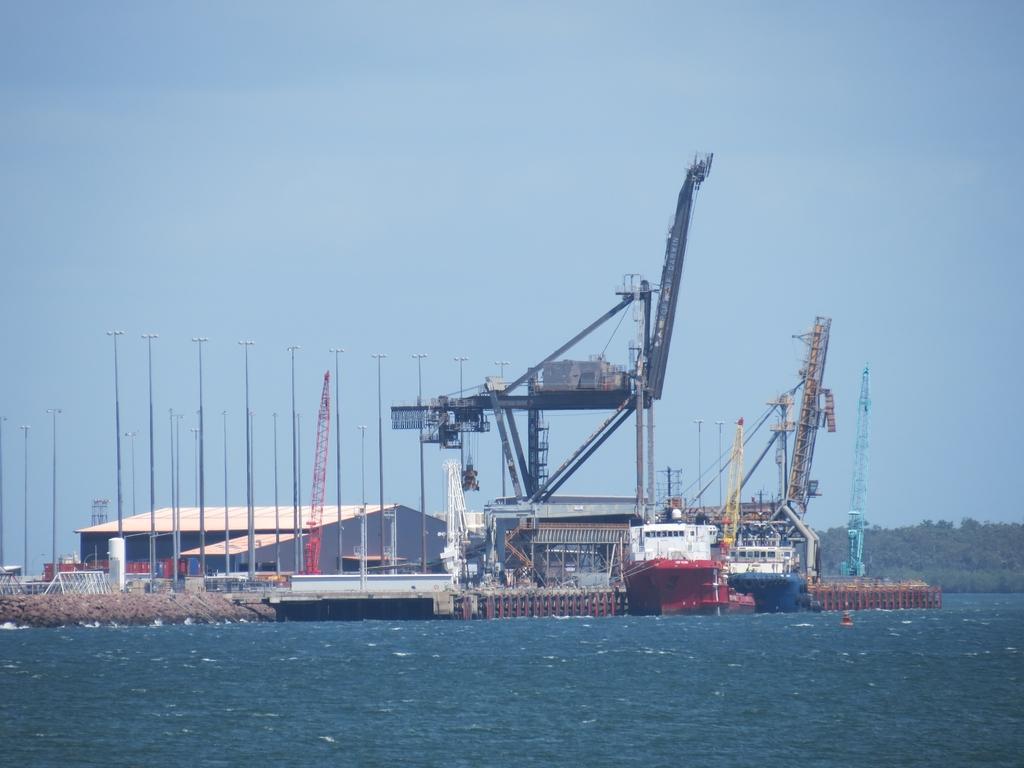Describe this image in one or two sentences. In this image I can see few boats are on the water. These boots are in different color. In the back I can see the shed and the crane and also I can see the blue sky. There are some trees to the right. 